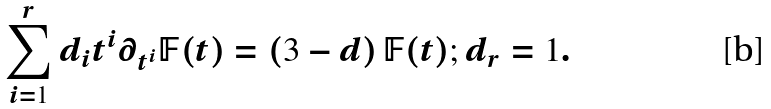<formula> <loc_0><loc_0><loc_500><loc_500>\sum _ { i = 1 } ^ { r } d _ { i } t ^ { i } \partial _ { t ^ { i } } \mathbb { F } ( t ) = \left ( 3 - d \right ) \mathbb { F } ( t ) ; d _ { r } = 1 .</formula> 